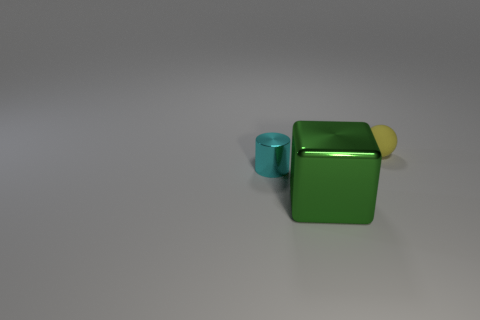Add 2 cylinders. How many objects exist? 5 Subtract all cylinders. How many objects are left? 2 Add 1 small cyan matte blocks. How many small cyan matte blocks exist? 1 Subtract 0 red cubes. How many objects are left? 3 Subtract all red balls. Subtract all large cubes. How many objects are left? 2 Add 3 cyan shiny objects. How many cyan shiny objects are left? 4 